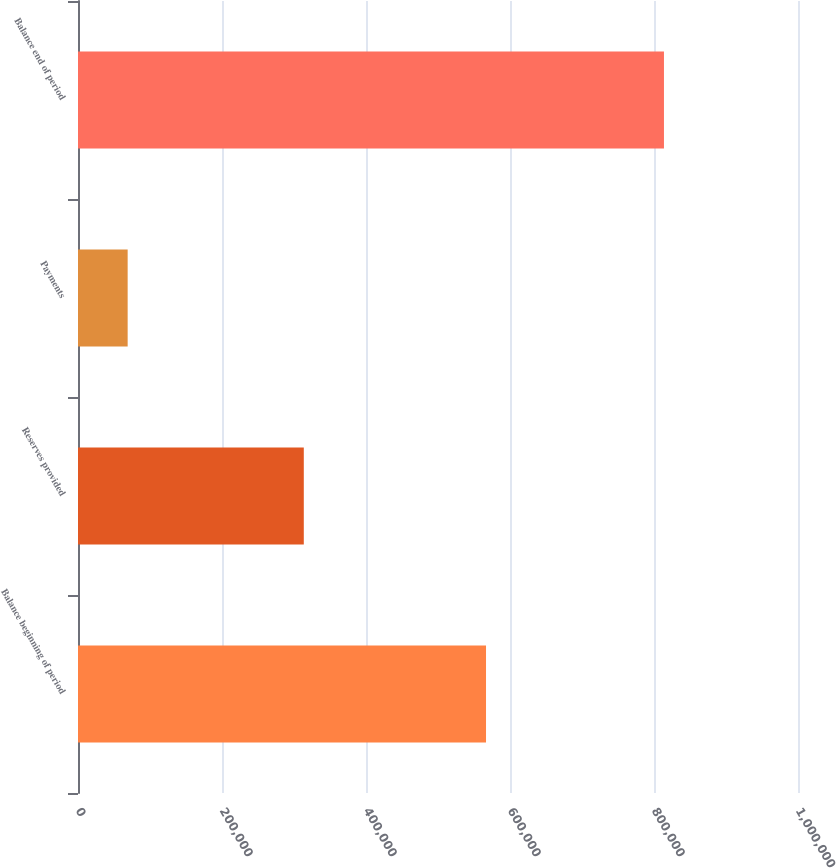Convert chart. <chart><loc_0><loc_0><loc_500><loc_500><bar_chart><fcel>Balance beginning of period<fcel>Reserves provided<fcel>Payments<fcel>Balance end of period<nl><fcel>566693<fcel>313606<fcel>68972<fcel>813841<nl></chart> 